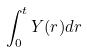<formula> <loc_0><loc_0><loc_500><loc_500>\int _ { 0 } ^ { t } Y ( r ) d r</formula> 